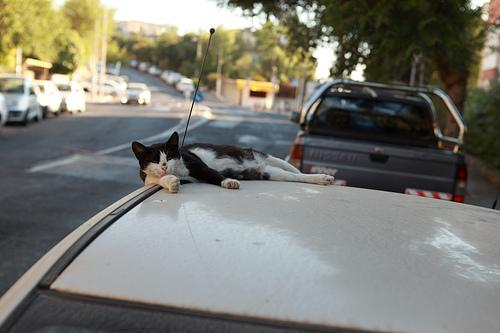Describe the most prominent object in the image and its activities, using a formal style. The dominant subject in the photograph is a monochromatic feline, situated atop an automobile, visibly relaxing. Imagine you are a storyteller; narrate the scene captured in the image. Once upon a time, on a serene street, a black and white cat found the perfect spot for a nap - the roof of a parked white car. What is the main animal doing in the image and where can it be found? The main animal, a black and white cat, is laying on the roof of a white car. Describe the primary subject of the image, highlighting the animal and the vehicle. The primary subject is a black and white cat lying comfortably on the roof of a parked white car. Provide a simple and concise description of the main focus of the image. A black and white cat is lounging on the roof of a white car parked on the street. Using a casual tone, describe what the cat in the image is doing and where it is. The black and white cat is just chilling on top of a white car, enjoying its day. Provide a brief overview of the scene, focusing on the primary subject and its position. The scene captures a black and white cat reclining on a white car's roof, parked along a tree-lined street. Using descriptive language, portray the main subject in the image and its actions. A graceful black and white cat languidly stretches out on the roof of a parked white car, basking in the peaceful ambiance of the street. Write a description of the image focused on the main subject using a poetic tone. A monochromatic feline finds solace on a car roof's cool surface, merging the worlds of nature and machine as it lounges in repose. Compose a short sentence that captures the central focus of the image. Cat lounges atop a parked car, basking in the serenity of the street scene. 